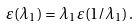Convert formula to latex. <formula><loc_0><loc_0><loc_500><loc_500>\varepsilon ( \lambda _ { 1 } ) = \lambda _ { 1 } \, \varepsilon ( 1 / \lambda _ { 1 } ) \, .</formula> 